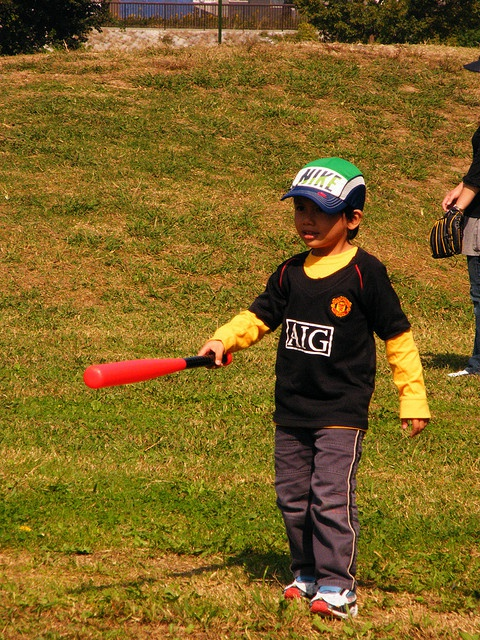Describe the objects in this image and their specific colors. I can see people in black, maroon, brown, and gold tones, people in black, olive, and tan tones, baseball bat in black, red, and salmon tones, and baseball glove in black, maroon, and olive tones in this image. 